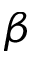Convert formula to latex. <formula><loc_0><loc_0><loc_500><loc_500>\beta</formula> 